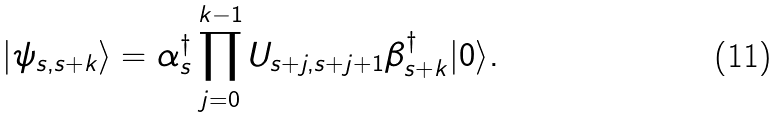<formula> <loc_0><loc_0><loc_500><loc_500>| \psi _ { s , s + k } \rangle = \alpha ^ { \dagger } _ { s } \prod _ { j = 0 } ^ { k - 1 } U _ { s + j , s + j + 1 } \beta ^ { \dagger } _ { s + k } | 0 \rangle .</formula> 